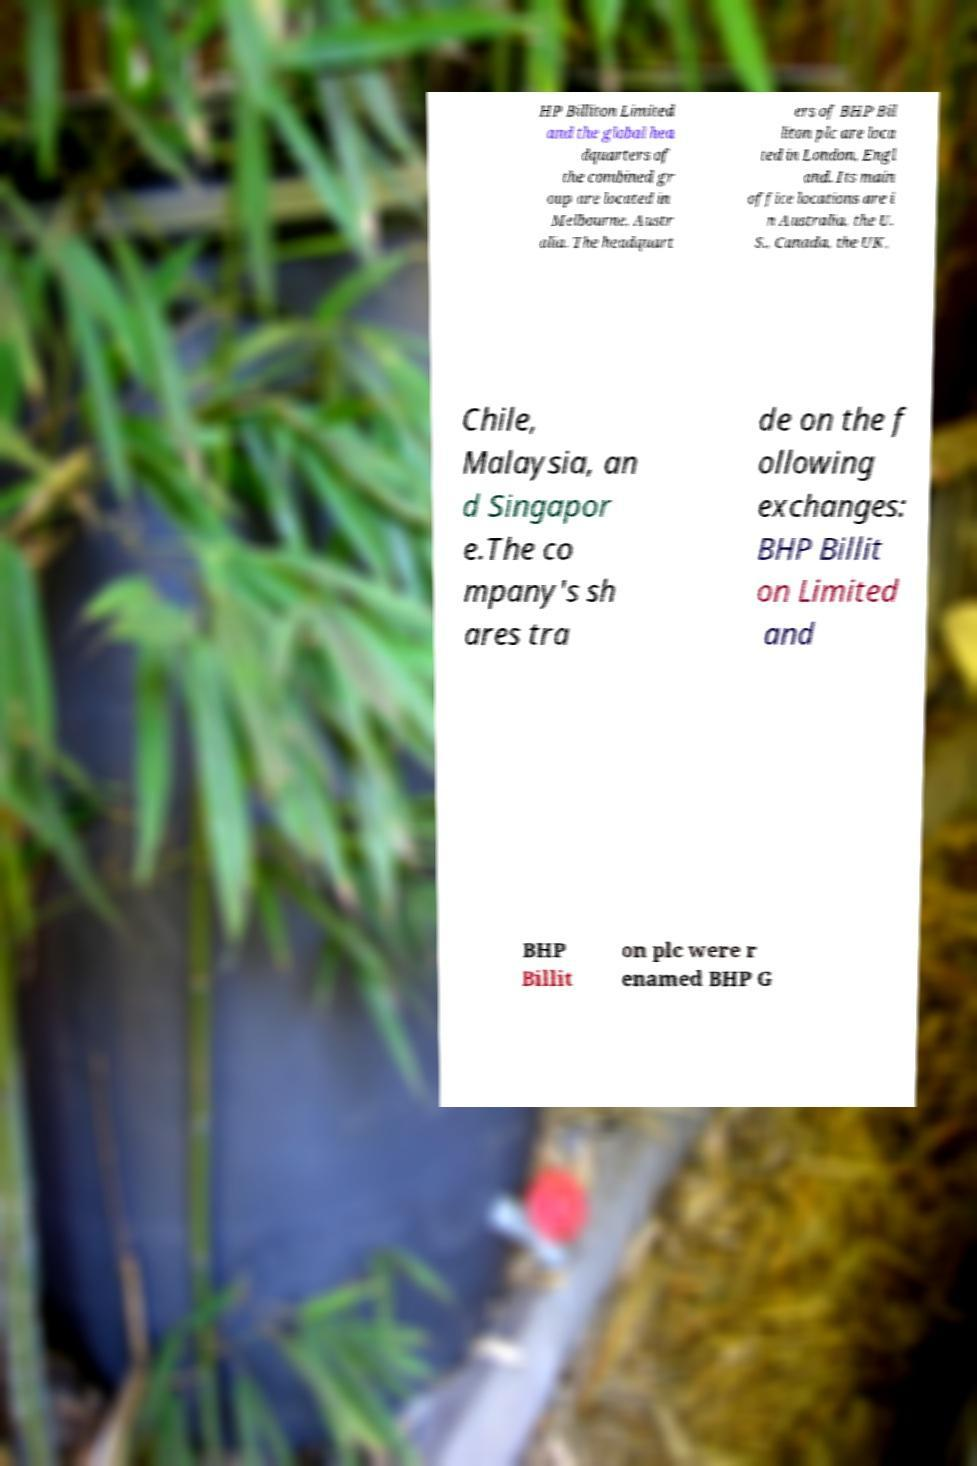Please read and relay the text visible in this image. What does it say? HP Billiton Limited and the global hea dquarters of the combined gr oup are located in Melbourne, Austr alia. The headquart ers of BHP Bil liton plc are loca ted in London, Engl and. Its main office locations are i n Australia, the U. S., Canada, the UK, Chile, Malaysia, an d Singapor e.The co mpany's sh ares tra de on the f ollowing exchanges: BHP Billit on Limited and BHP Billit on plc were r enamed BHP G 